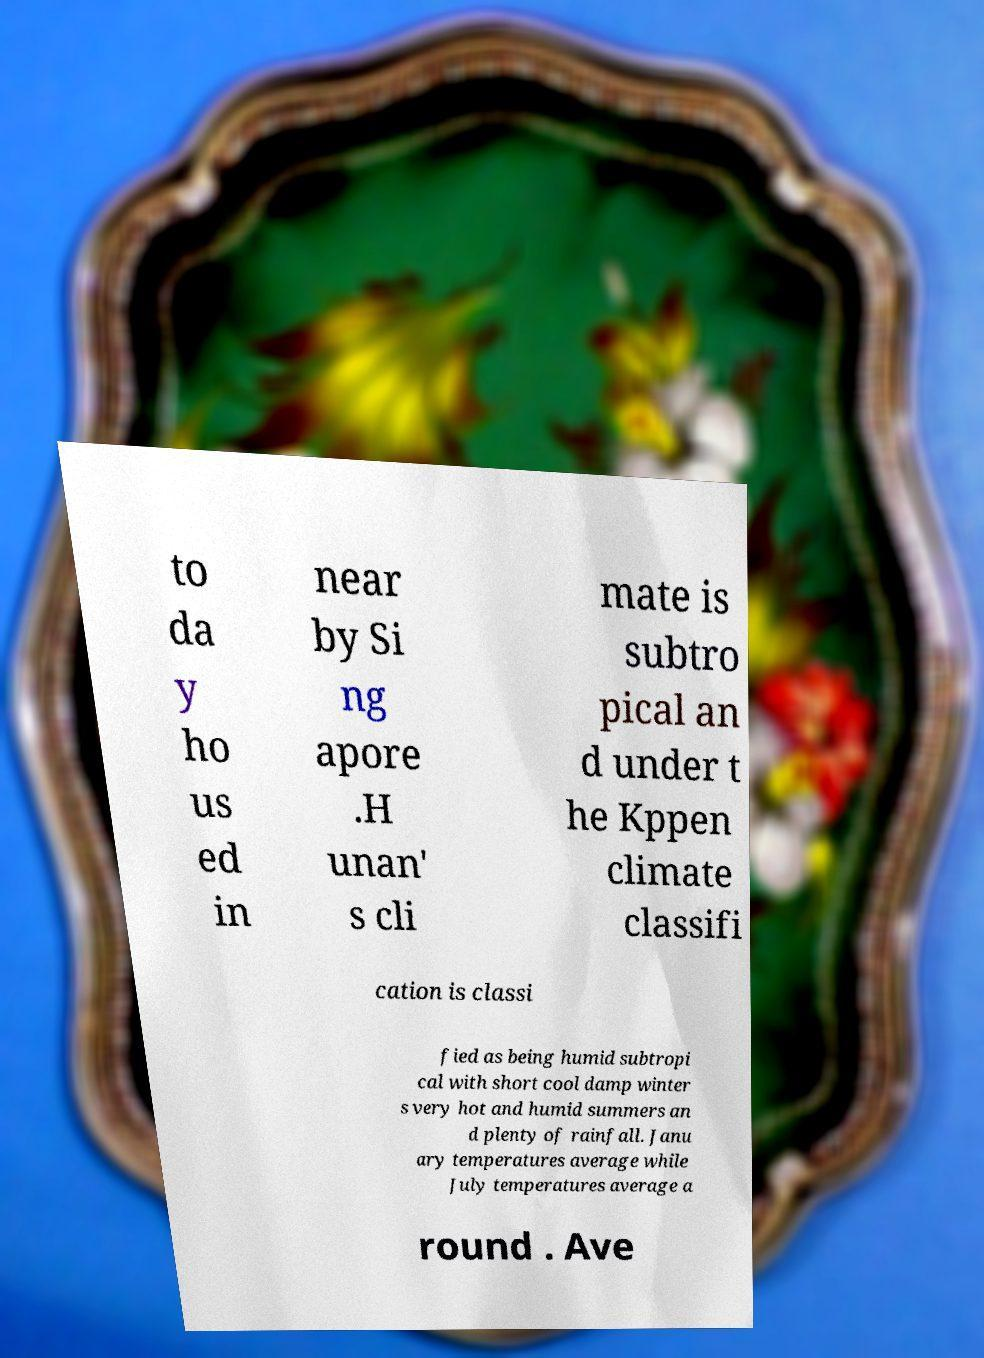What messages or text are displayed in this image? I need them in a readable, typed format. to da y ho us ed in near by Si ng apore .H unan' s cli mate is subtro pical an d under t he Kppen climate classifi cation is classi fied as being humid subtropi cal with short cool damp winter s very hot and humid summers an d plenty of rainfall. Janu ary temperatures average while July temperatures average a round . Ave 